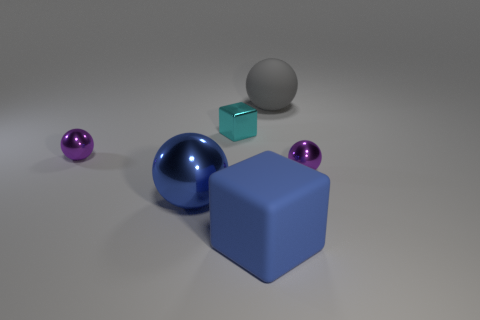There is a big ball that is the same material as the tiny cyan thing; what is its color?
Offer a very short reply. Blue. Are there fewer large blue matte things to the left of the cyan shiny object than big blocks behind the large blue metallic thing?
Your response must be concise. No. There is a large sphere that is to the left of the cyan object; is its color the same as the object that is on the right side of the gray object?
Keep it short and to the point. No. Is there another big object made of the same material as the cyan object?
Provide a succinct answer. Yes. There is a purple object that is behind the small purple metal sphere that is right of the large gray sphere; what is its size?
Provide a succinct answer. Small. Are there more tiny brown rubber balls than blue shiny objects?
Provide a short and direct response. No. There is a purple metal thing on the right side of the metal block; does it have the same size as the large blue metallic thing?
Keep it short and to the point. No. How many large metallic things have the same color as the rubber cube?
Make the answer very short. 1. Do the large blue metal object and the blue rubber object have the same shape?
Your answer should be very brief. No. The blue matte thing that is the same shape as the tiny cyan object is what size?
Provide a short and direct response. Large. 